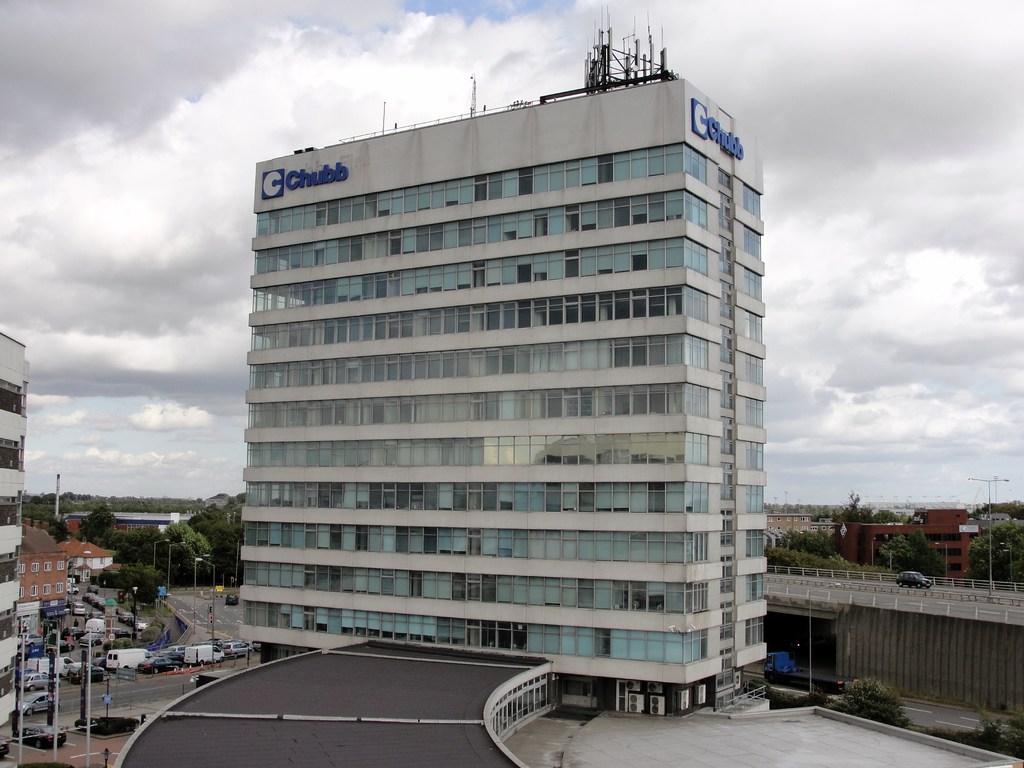Can you describe this image briefly? In this picture we can see buildings,here we can see vehicles on the road and we can see sky in the background. 